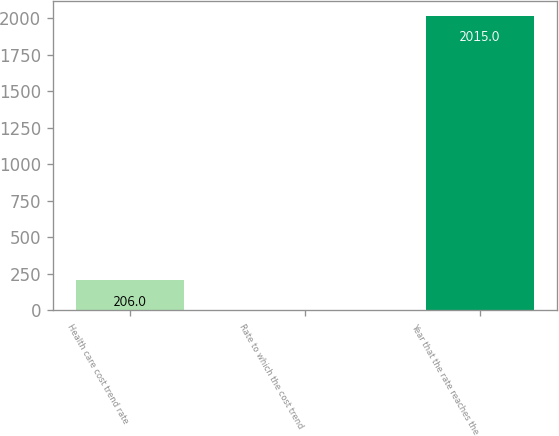<chart> <loc_0><loc_0><loc_500><loc_500><bar_chart><fcel>Health care cost trend rate<fcel>Rate to which the cost trend<fcel>Year that the rate reaches the<nl><fcel>206<fcel>5<fcel>2015<nl></chart> 